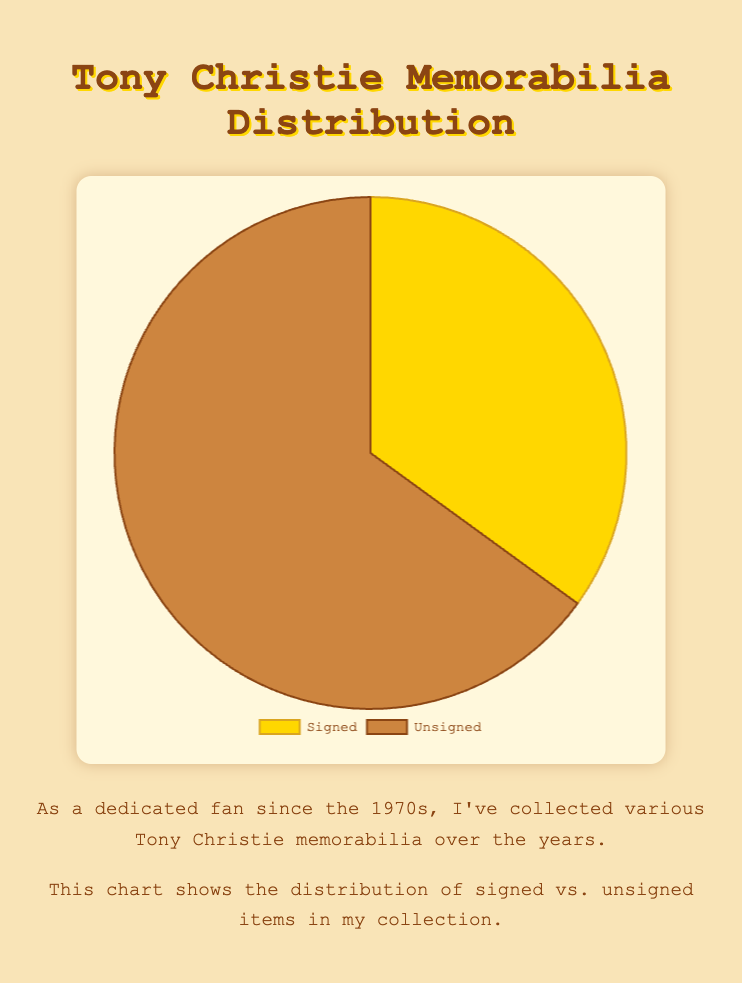What percentage of Tony Christie memorabilia is signed? According to the pie chart, the percentage of signed memorabilia is shown in the 'Signed' slice as 35%.
Answer: 35% What is the larger category, signed or unsigned memorabilia? Comparing the two categories, 'Signed' shows 35% while 'Unsigned' shows 65%, indicating 'Unsigned' is larger.
Answer: Unsigned How much more unsigned memorabilia is there compared to signed memorabilia? The signed percentage is 35% and unsigned is 65%. The difference is 65% - 35% = 30%.
Answer: 30% What is the ratio of signed to unsigned memorabilia? The signed is 35% and unsigned is 65%. The ratio of signed to unsigned is 35:65 which simplifies to 7:13.
Answer: 7:13 If you combine the signed and unsigned memorabilia, what percentage does each category represent out of the total? The total of both categories is 100%. Signed memorabilia represents 35% of the total, while unsigned represents 65%.
Answer: Signed: 35%, Unsigned: 65% Which category is represented by the golden color in the pie chart? In the pie chart, the golden color represents the 'Signed' memorabilia category.
Answer: Signed What would the percentages be if you had 5% more signed memorabilia and 5% less unsigned memorabilia? Initially, signed is 35% and unsigned is 65%. Adding 5% to signed makes it 40%, and subtracting 5% from unsigned makes it 60%.
Answer: Signed: 40%, Unsigned: 60% What fraction of the memorabilia is unsigned? The pie chart shows that unsigned memorabilia is 65%, which can be represented as 65/100 or simplified to 13/20.
Answer: 13/20 If the collection had an equal number of signed and unsigned items, what would be the percentage of each type? If there were an equal number of signed and unsigned items, each type would represent half of the total collection, which means 50% each.
Answer: Signed: 50%, Unsigned: 50% What's the sum of the percentages of signed and unsigned memorabilia? The percentages of signed and unsigned memorabilia are 35% and 65% respectively. Summing these gives 35% + 65% = 100%.
Answer: 100% 